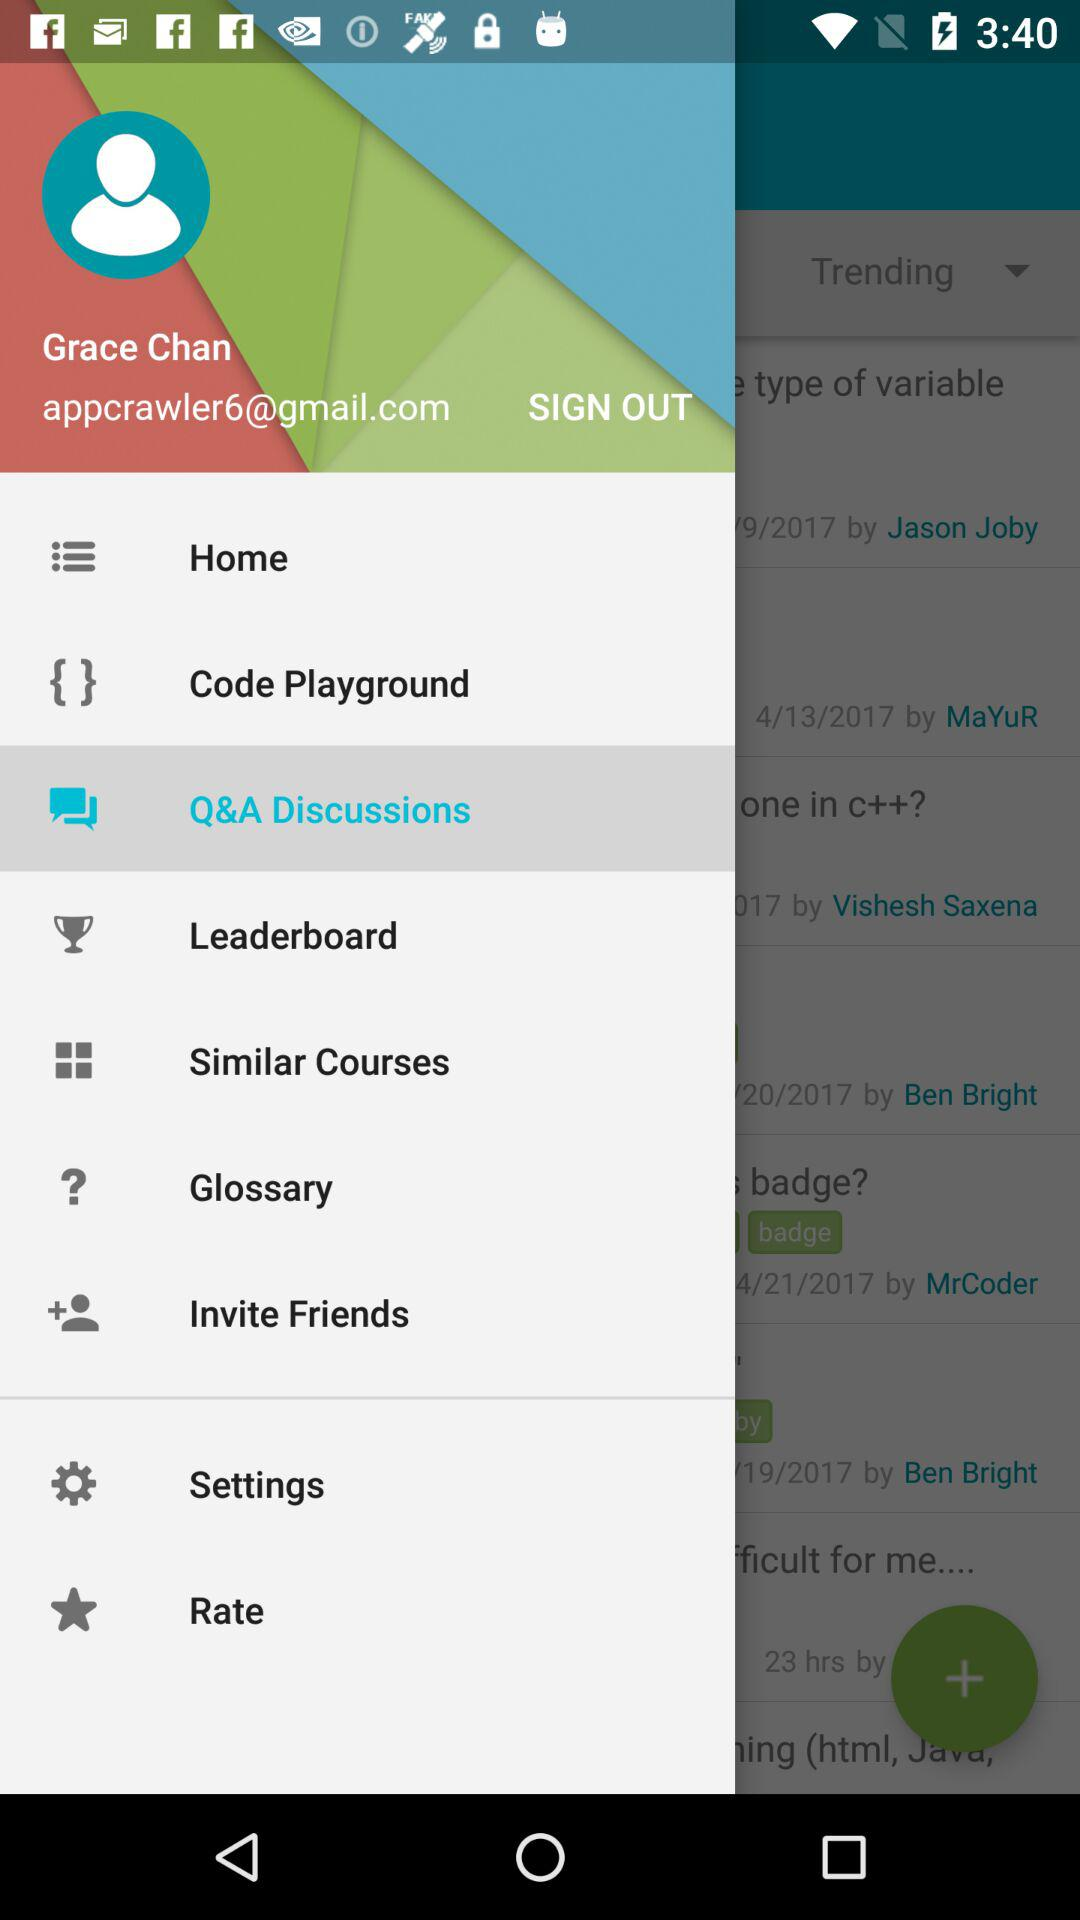What is the name of the user? The name of the user is Grace Chan. 